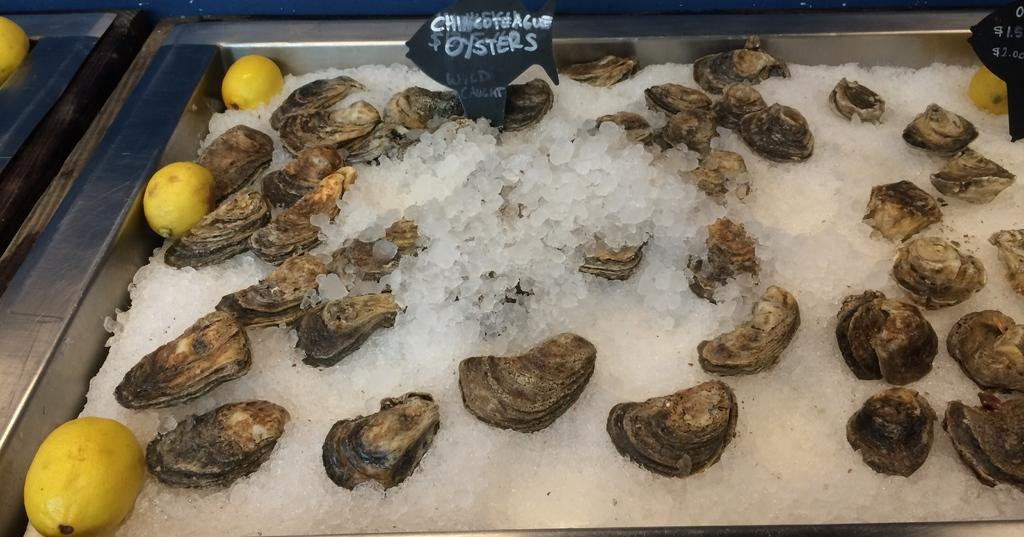What type of natural objects can be seen in the image? There are sea shells in the image. What is stored in the steel container in the image? There is salt in a steel container in the image. What type of fruit is present in the image? There are lemons in the image. How many name boards are visible in the image? There are two name boards in the image. What type of ring can be seen on the train in the image? There is no train present in the image, so there is no ring associated with it. 